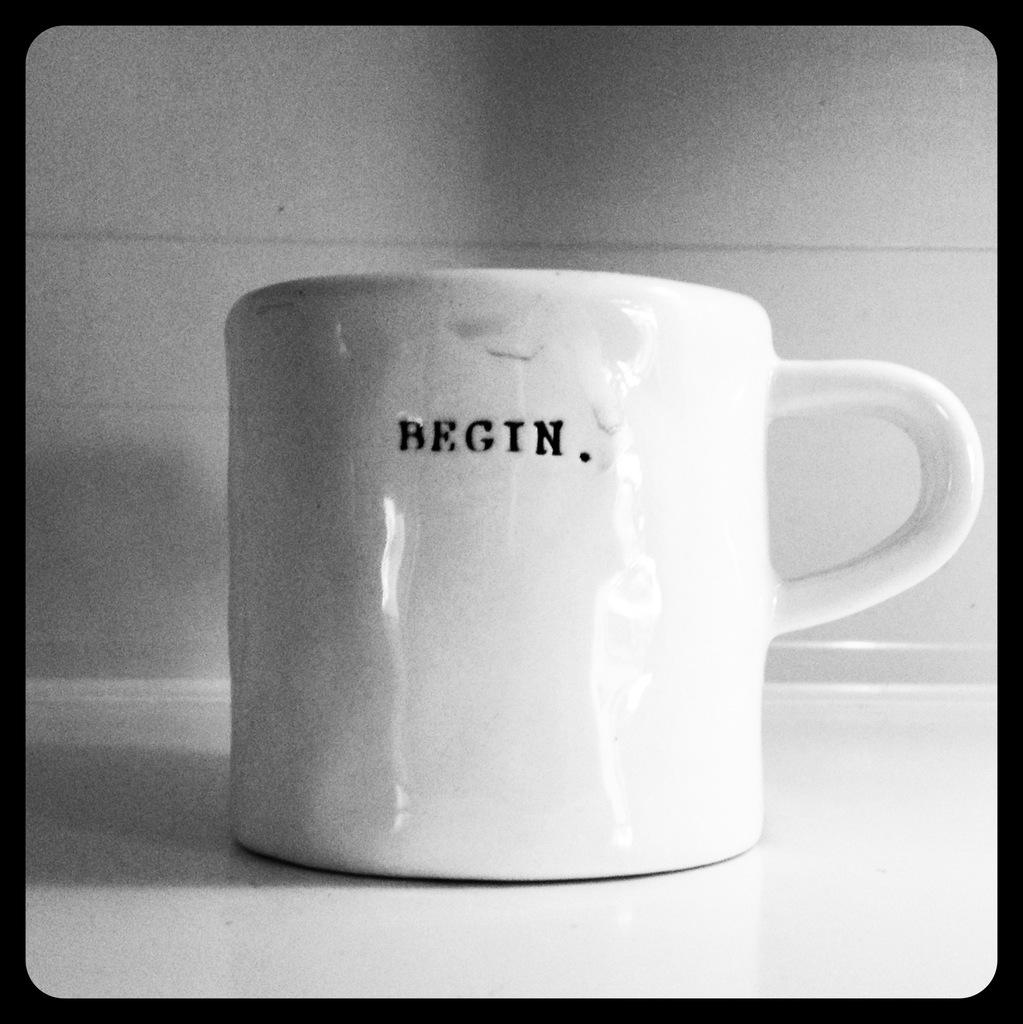Provide a one-sentence caption for the provided image. A white mug with "Begin" written on it in small text. 